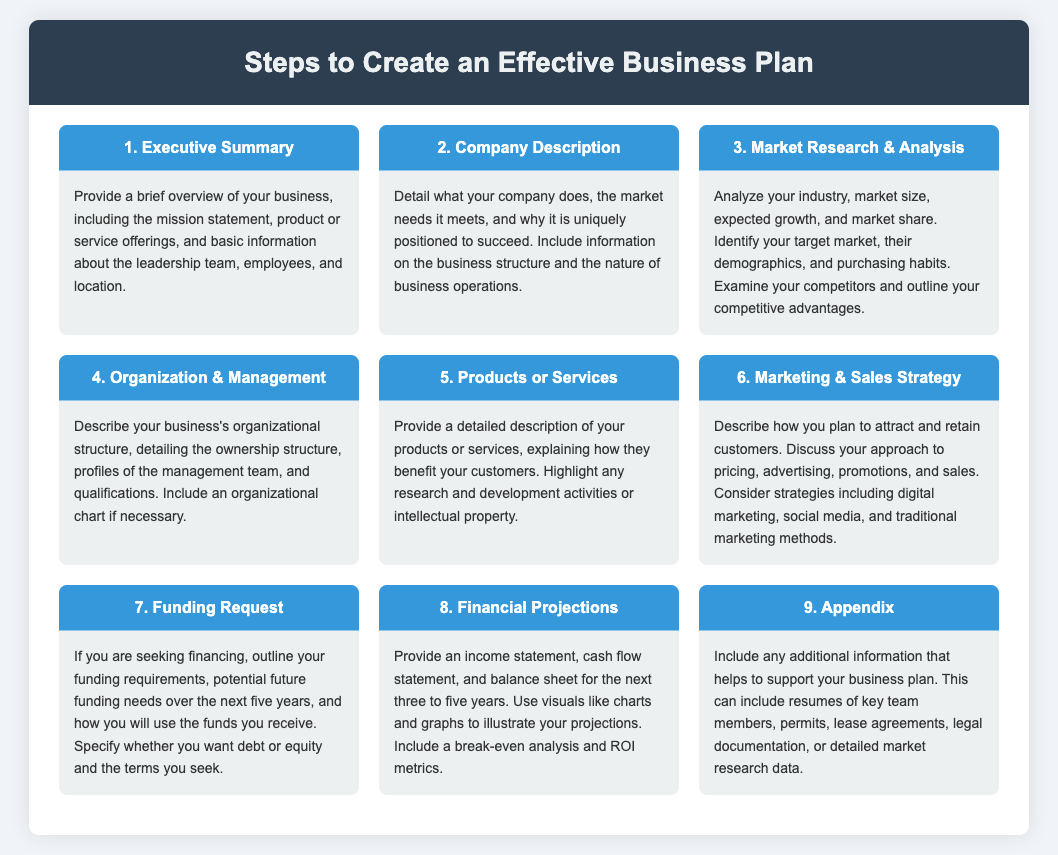What is the first step in creating a business plan? The first step outlined in the document is titled "Executive Summary".
Answer: Executive Summary What does the Company Description focus on? The Company Description details what the company does, market needs it meets, and its unique positioning for success.
Answer: What the company does Which step involves analyzing industry and market size? The "Market Research & Analysis" step involves this analysis to identify target market and competitors.
Answer: Market Research & Analysis What is included in the Funding Request step? The Funding Request outlines funding requirements, future needs, and specifies debt or equity terms.
Answer: Funding requirements How many years are the Financial Projections anticipated for? The Financial Projections are typically provided for the next three to five years.
Answer: Three to five years What is the final step of the business plan according to the infographic? The final step according to the infographic is titled "Appendix".
Answer: Appendix What type of information should be included in the appendix? The appendix should include resumes, permits, and detailed market research data as supportive information.
Answer: Resumes, permits, detailed market research data Which step emphasizes customer attraction and retention strategies? The "Marketing & Sales Strategy" step emphasizes this aspect.
Answer: Marketing & Sales Strategy 